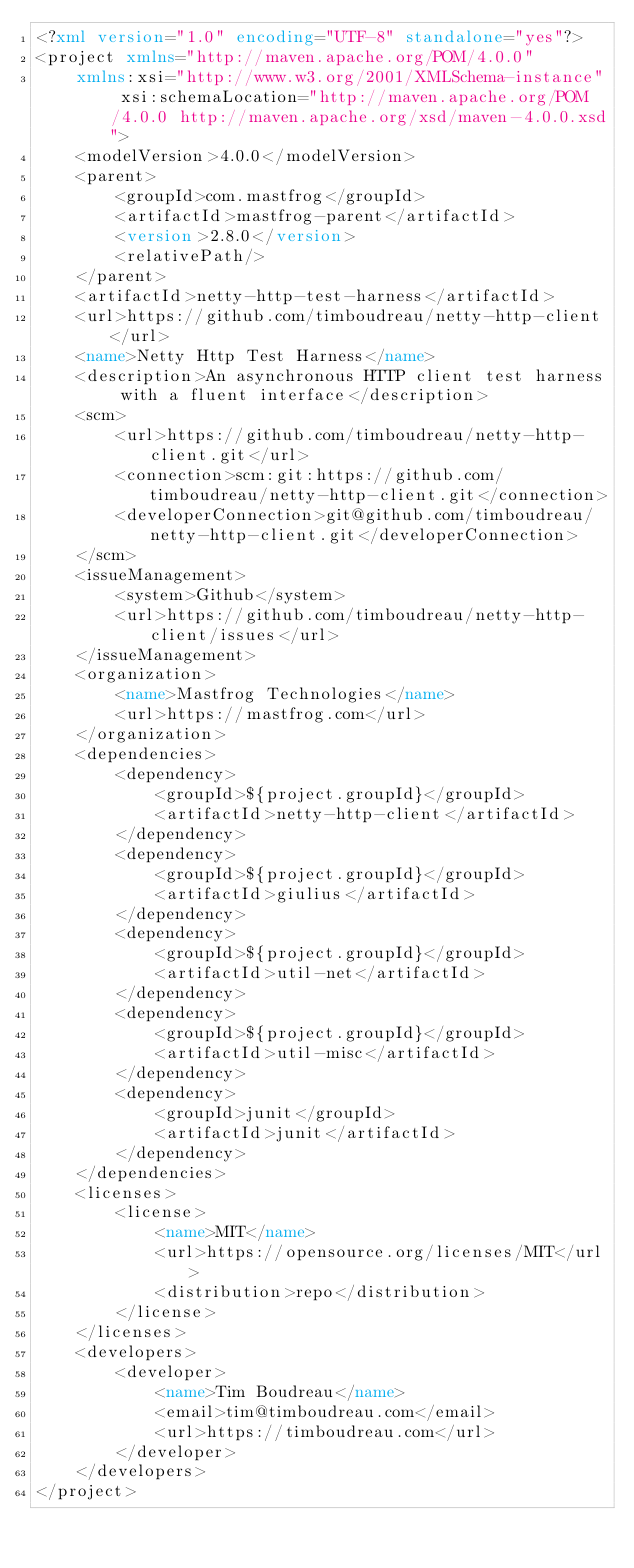<code> <loc_0><loc_0><loc_500><loc_500><_XML_><?xml version="1.0" encoding="UTF-8" standalone="yes"?>
<project xmlns="http://maven.apache.org/POM/4.0.0"
    xmlns:xsi="http://www.w3.org/2001/XMLSchema-instance" xsi:schemaLocation="http://maven.apache.org/POM/4.0.0 http://maven.apache.org/xsd/maven-4.0.0.xsd">
    <modelVersion>4.0.0</modelVersion>
    <parent>
        <groupId>com.mastfrog</groupId>
        <artifactId>mastfrog-parent</artifactId>
        <version>2.8.0</version>
        <relativePath/>
    </parent>
    <artifactId>netty-http-test-harness</artifactId>
    <url>https://github.com/timboudreau/netty-http-client</url>
    <name>Netty Http Test Harness</name>
    <description>An asynchronous HTTP client test harness with a fluent interface</description>
    <scm>
        <url>https://github.com/timboudreau/netty-http-client.git</url>
        <connection>scm:git:https://github.com/timboudreau/netty-http-client.git</connection>
        <developerConnection>git@github.com/timboudreau/netty-http-client.git</developerConnection>
    </scm>
    <issueManagement>
        <system>Github</system>
        <url>https://github.com/timboudreau/netty-http-client/issues</url>
    </issueManagement>
    <organization>
        <name>Mastfrog Technologies</name>
        <url>https://mastfrog.com</url>
    </organization>
    <dependencies>
        <dependency>
            <groupId>${project.groupId}</groupId>
            <artifactId>netty-http-client</artifactId>
        </dependency>
        <dependency>
            <groupId>${project.groupId}</groupId>
            <artifactId>giulius</artifactId>
        </dependency>
        <dependency>
            <groupId>${project.groupId}</groupId>
            <artifactId>util-net</artifactId>
        </dependency>
        <dependency>
            <groupId>${project.groupId}</groupId>
            <artifactId>util-misc</artifactId>
        </dependency>
        <dependency>
            <groupId>junit</groupId>
            <artifactId>junit</artifactId>
        </dependency>
    </dependencies>
    <licenses>
        <license>
            <name>MIT</name>
            <url>https://opensource.org/licenses/MIT</url>
            <distribution>repo</distribution>
        </license>
    </licenses>
    <developers>
        <developer>
            <name>Tim Boudreau</name>
            <email>tim@timboudreau.com</email>
            <url>https://timboudreau.com</url>
        </developer>
    </developers>
</project>
</code> 